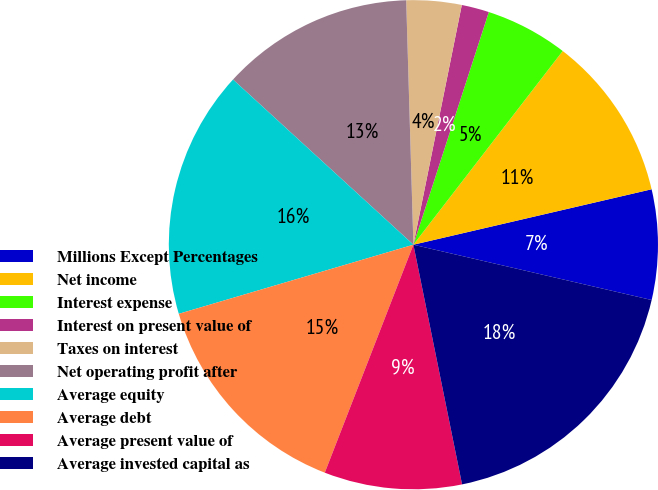Convert chart. <chart><loc_0><loc_0><loc_500><loc_500><pie_chart><fcel>Millions Except Percentages<fcel>Net income<fcel>Interest expense<fcel>Interest on present value of<fcel>Taxes on interest<fcel>Net operating profit after<fcel>Average equity<fcel>Average debt<fcel>Average present value of<fcel>Average invested capital as<nl><fcel>7.27%<fcel>10.91%<fcel>5.46%<fcel>1.82%<fcel>3.64%<fcel>12.73%<fcel>16.36%<fcel>14.54%<fcel>9.09%<fcel>18.18%<nl></chart> 